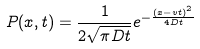Convert formula to latex. <formula><loc_0><loc_0><loc_500><loc_500>P ( x , t ) = \frac { 1 } { 2 \sqrt { \pi D t } } e ^ { - \frac { ( x - v t ) ^ { 2 } } { 4 D t } }</formula> 